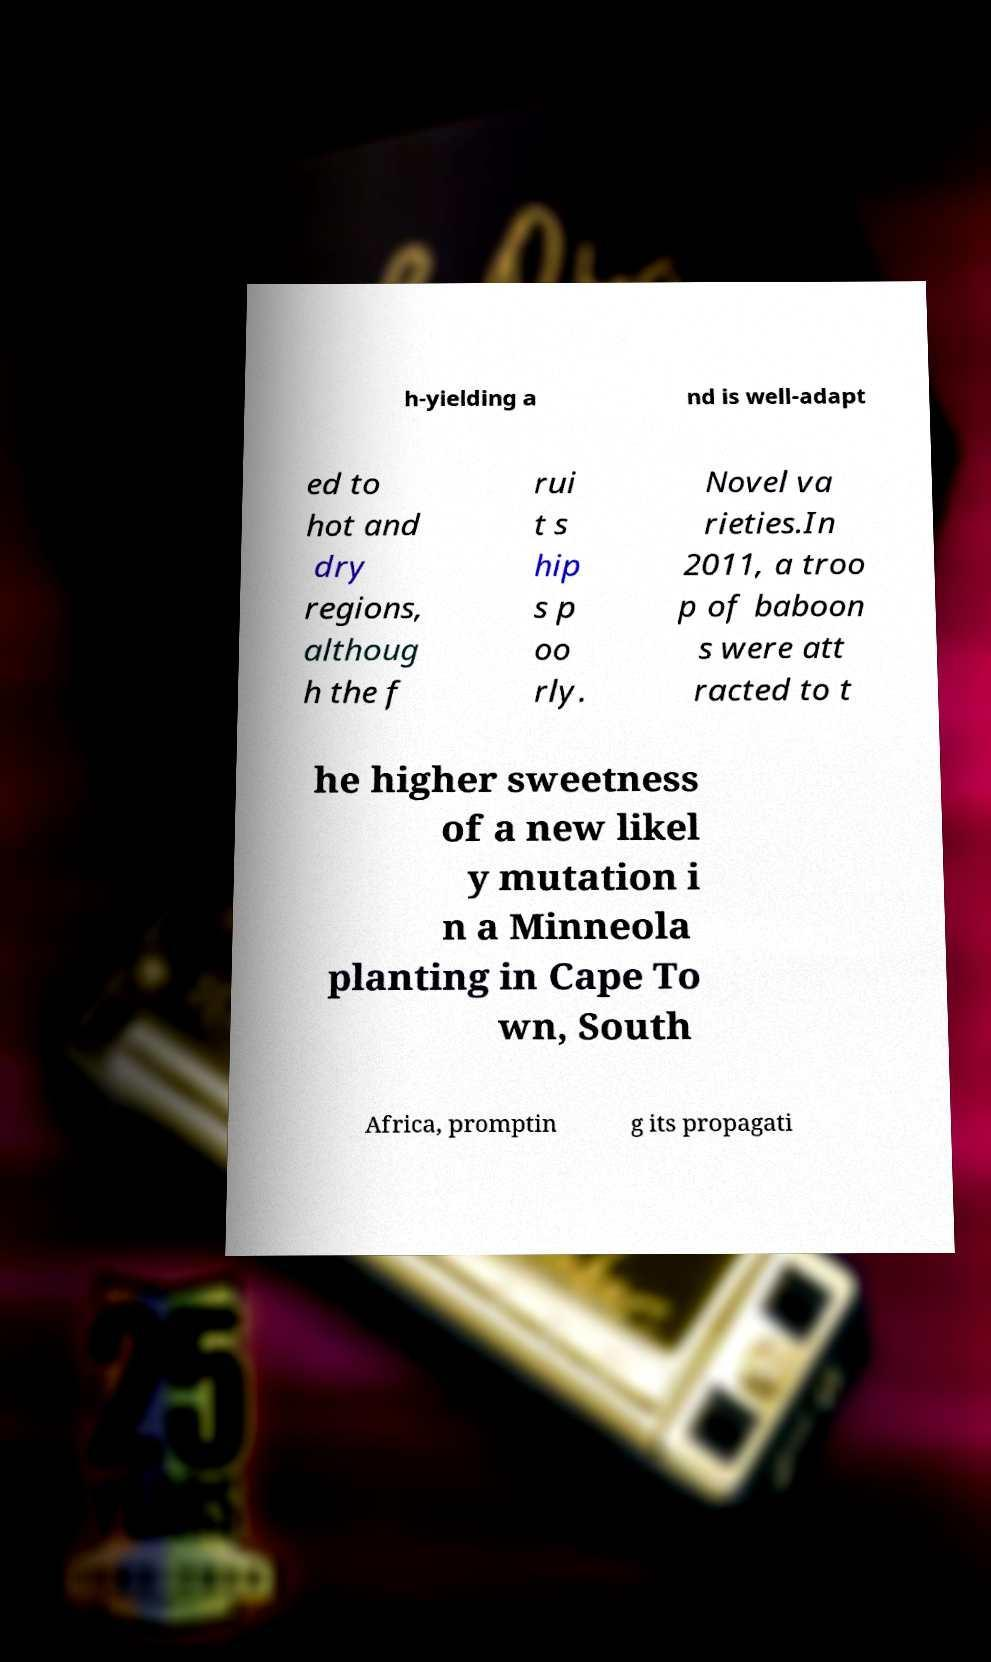Could you extract and type out the text from this image? h-yielding a nd is well-adapt ed to hot and dry regions, althoug h the f rui t s hip s p oo rly. Novel va rieties.In 2011, a troo p of baboon s were att racted to t he higher sweetness of a new likel y mutation i n a Minneola planting in Cape To wn, South Africa, promptin g its propagati 